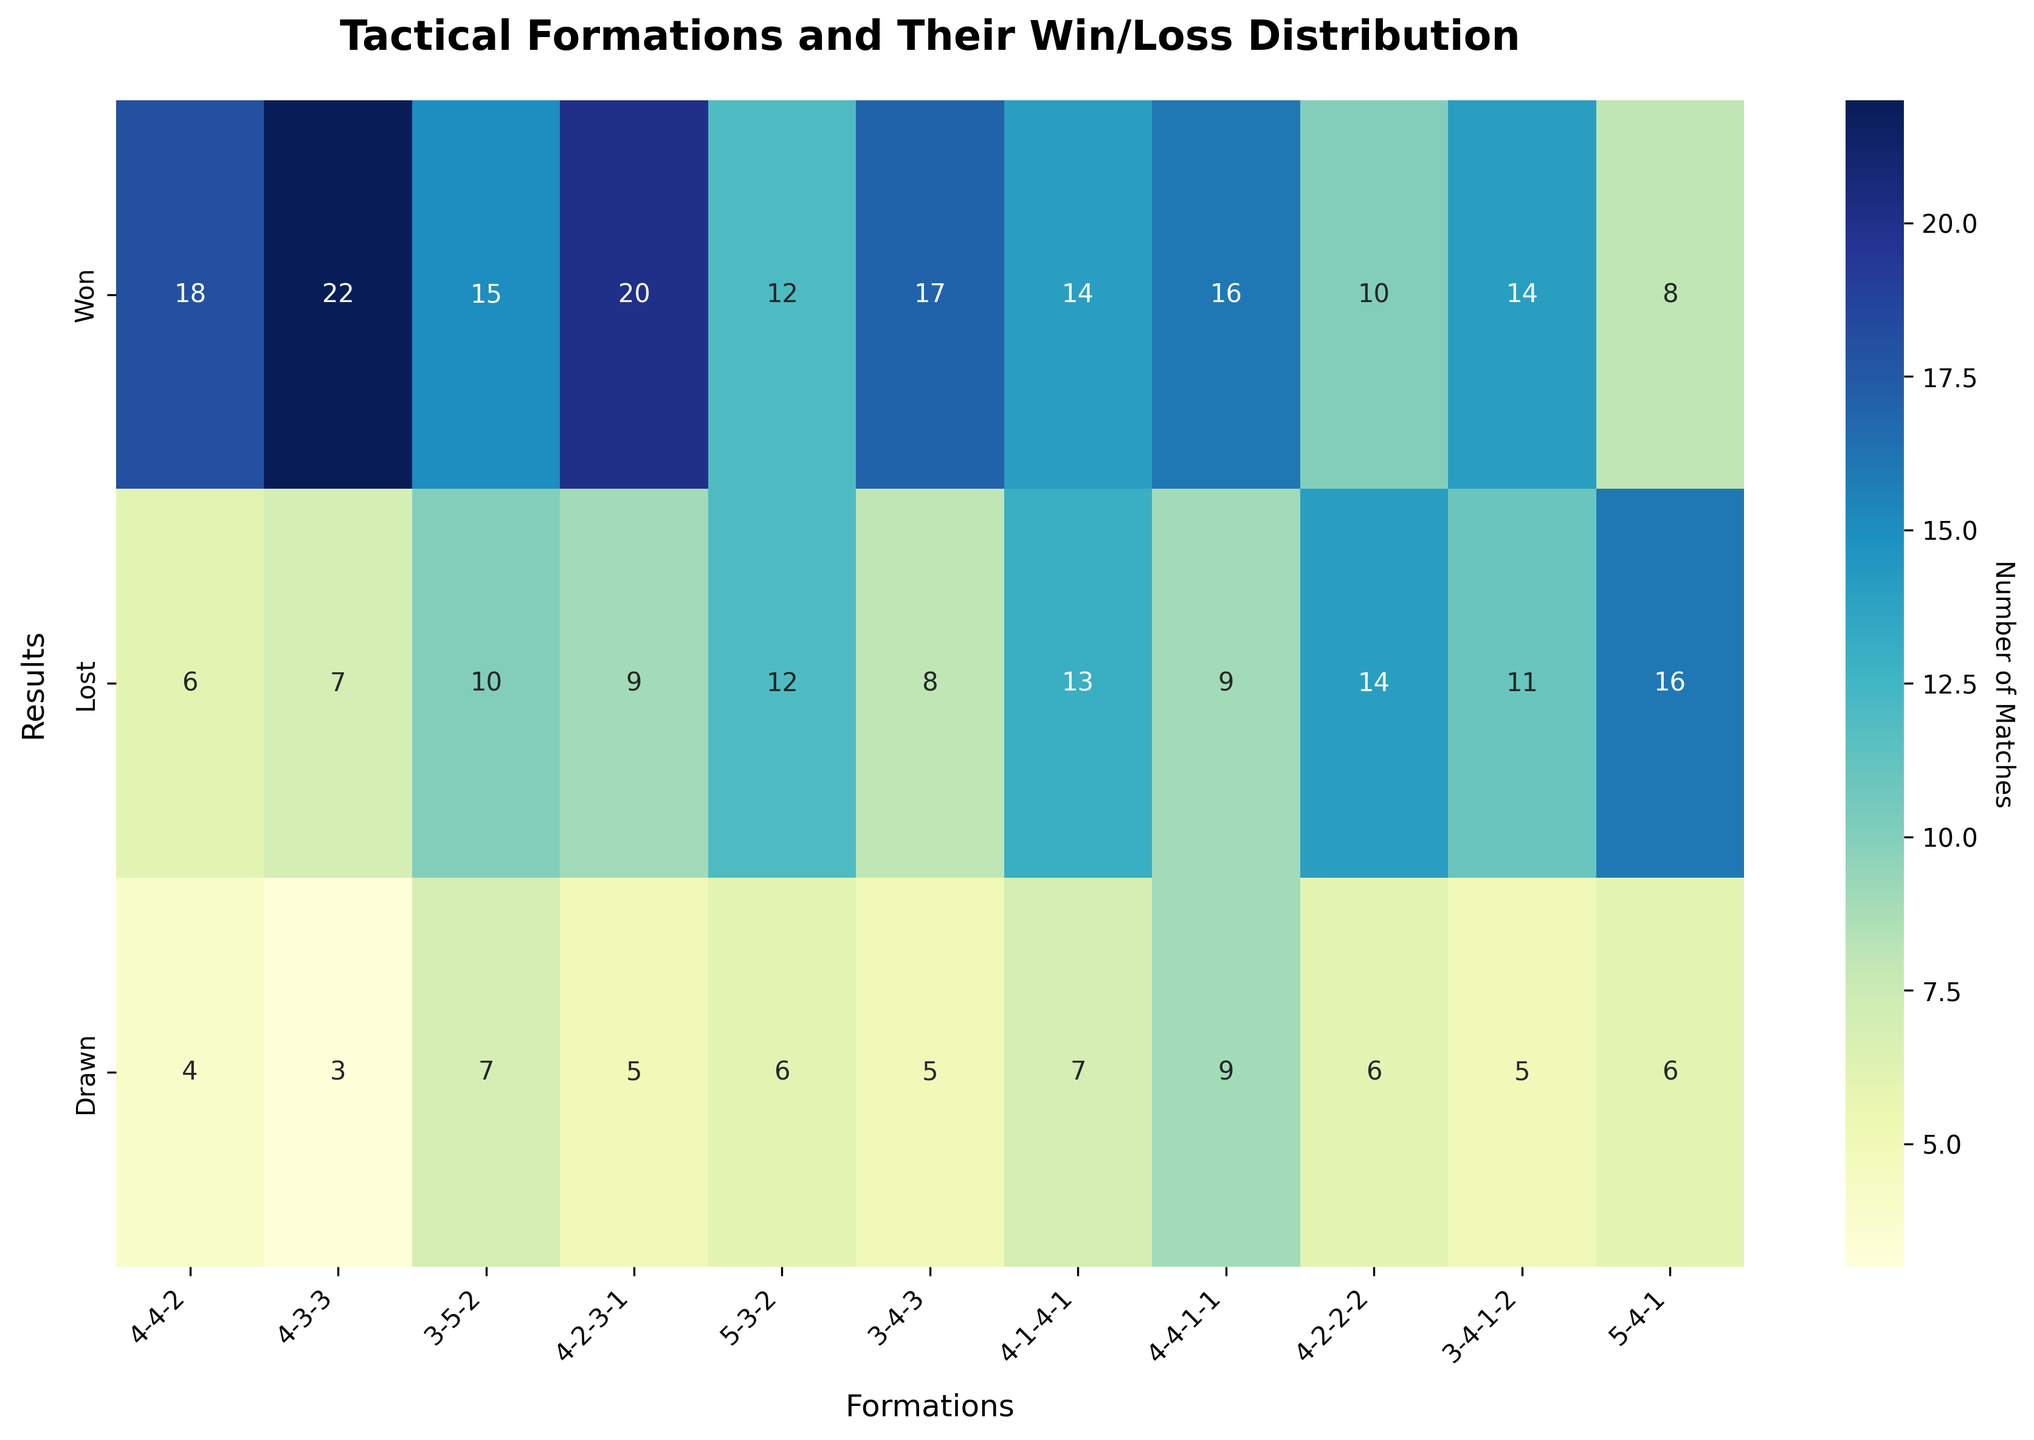What's the title of the figure? The title of the figure is displayed at the top, usually in bold and larger font size.
Answer: Tactical Formations and Their Win/Loss Distribution Which formation has the highest number of wins? To identify the formation with the highest number of wins, look for the maximum values in the 'Won' row. The heatmap will show a specific numerical value for each formation.
Answer: 4-3-3 How many total matches were drawn for the formation 4-4-1-1? To find the total number of drawn matches for the formation 4-4-1-1, locate the intersection of the 'Drawn' row and the 4-4-1-1 column in the heatmap.
Answer: 9 Which formation has the fewest losses? To identify the formation with the fewest losses, look for the minimum values in the 'Lost' row. Check each cell in this row to find the smallest number.
Answer: 4-4-2 What is the total number of matches played in the 4-2-2-2 formation? The total number of matches played can be calculated by summing the values in the 'Won', 'Lost', and 'Drawn' rows for the 4-2-2-2 formation. So, 10 (Won) + 14 (Lost) + 6 (Drawn).
Answer: 30 Which formations have an equal number of wins and draws? To find formations with an equal number of wins and draws, compare the values in the 'Won' and 'Drawn' rows for each formation. Look for pairs where the numbers match.
Answer: None What is the average number of losses across all formations? To calculate the average number of losses, sum the values in the 'Lost' row and then divide by the number of formations. Sum = (6 + 7 + 10 + 9 + 12 + 8 + 13 + 9 + 14 + 11 + 16) = 115. Number of formations = 11. So, average = 115 / 11.
Answer: 10.45 Which formation used has the most balanced win/loss distribution? To determine the most balanced win/loss distribution, find the formation where the values in the 'Won' and 'Lost' rows are closest to each other.
Answer: 4-4-1-1 In which formation did the team lose the most matches? To identify the formation with the maximum losses, look for the highest number in the 'Lost' row within the heatmap.
Answer: 5-4-1 